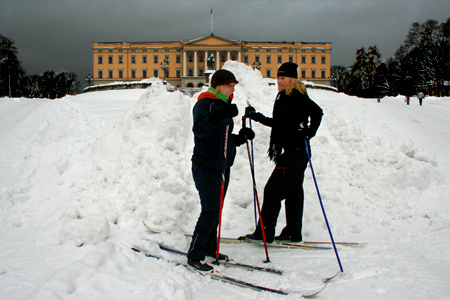Who wears the cap? The girl is wearing the cap. 